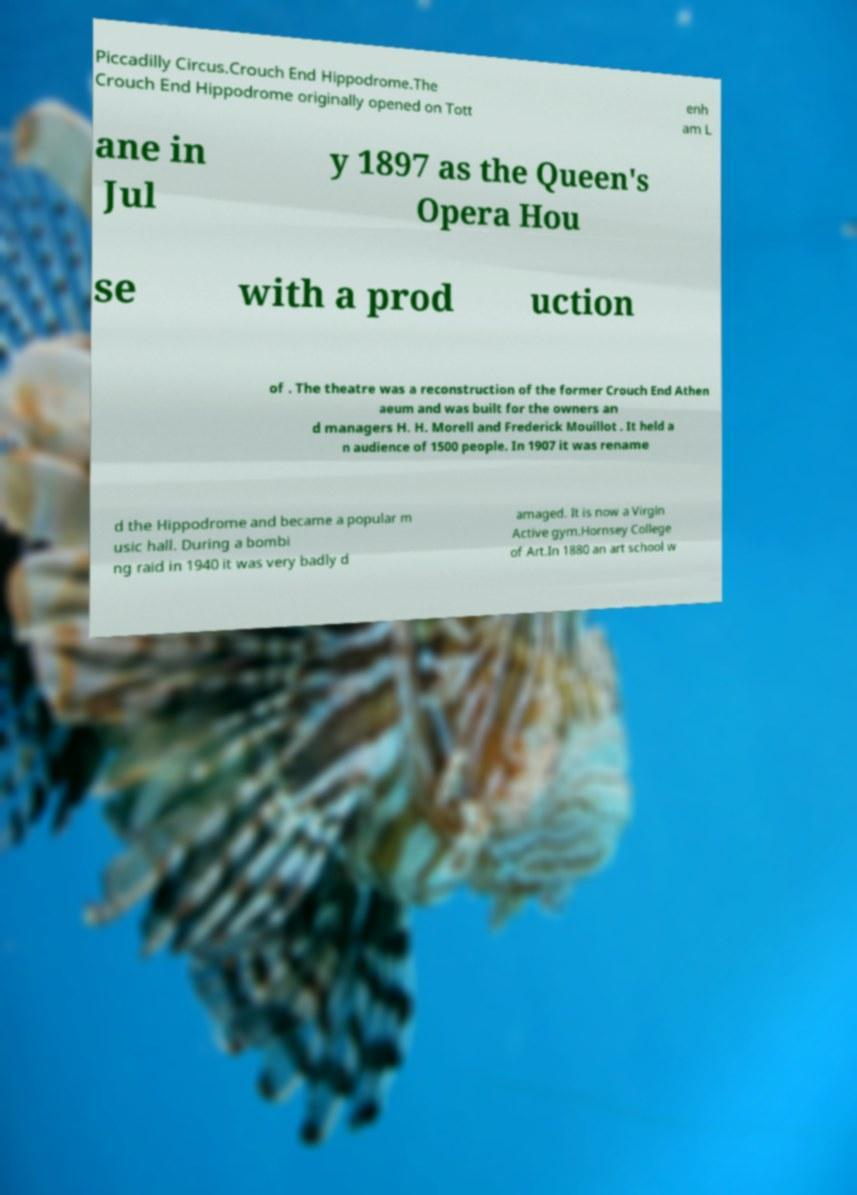What messages or text are displayed in this image? I need them in a readable, typed format. Piccadilly Circus.Crouch End Hippodrome.The Crouch End Hippodrome originally opened on Tott enh am L ane in Jul y 1897 as the Queen's Opera Hou se with a prod uction of . The theatre was a reconstruction of the former Crouch End Athen aeum and was built for the owners an d managers H. H. Morell and Frederick Mouillot . It held a n audience of 1500 people. In 1907 it was rename d the Hippodrome and became a popular m usic hall. During a bombi ng raid in 1940 it was very badly d amaged. It is now a Virgin Active gym.Hornsey College of Art.In 1880 an art school w 